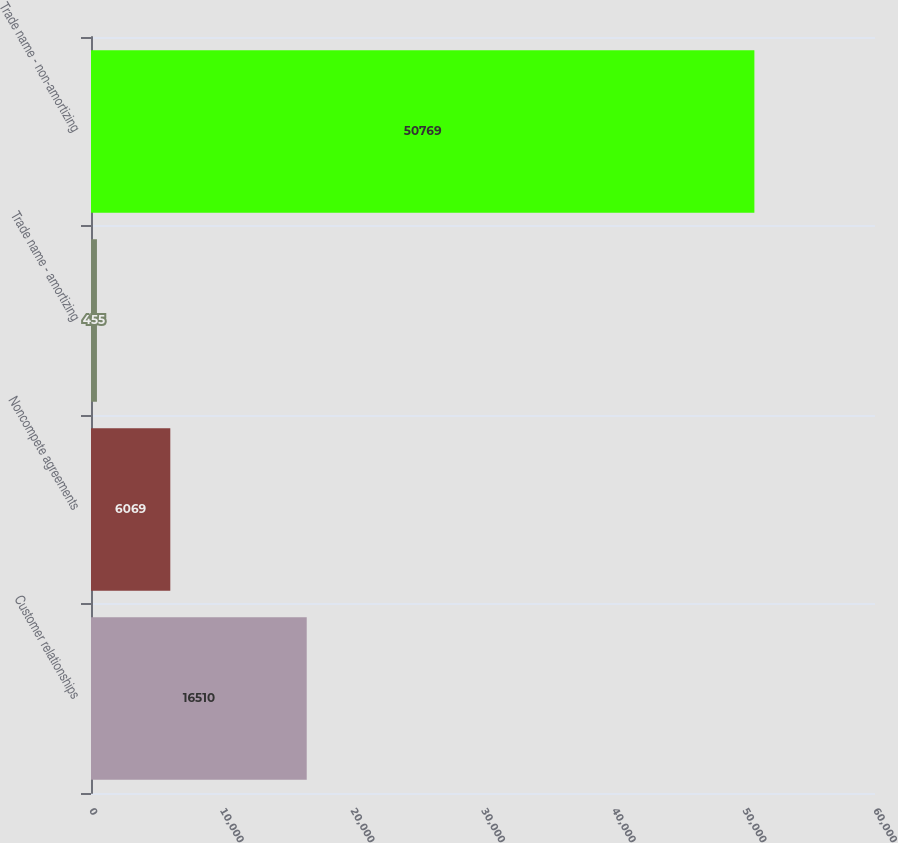<chart> <loc_0><loc_0><loc_500><loc_500><bar_chart><fcel>Customer relationships<fcel>Noncompete agreements<fcel>Trade name - amortizing<fcel>Trade name - non-amortizing<nl><fcel>16510<fcel>6069<fcel>455<fcel>50769<nl></chart> 